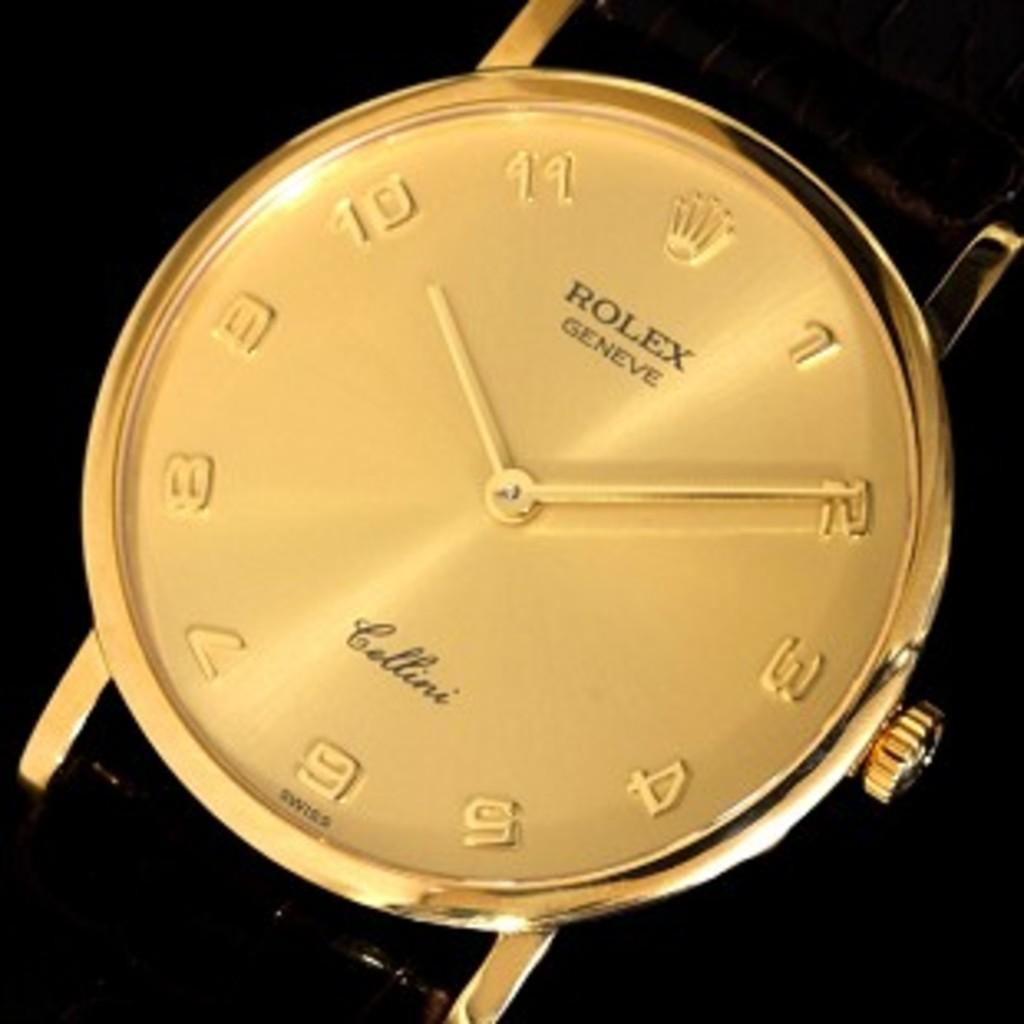<image>
Present a compact description of the photo's key features. A golden Rolex watch with a black arm band. 